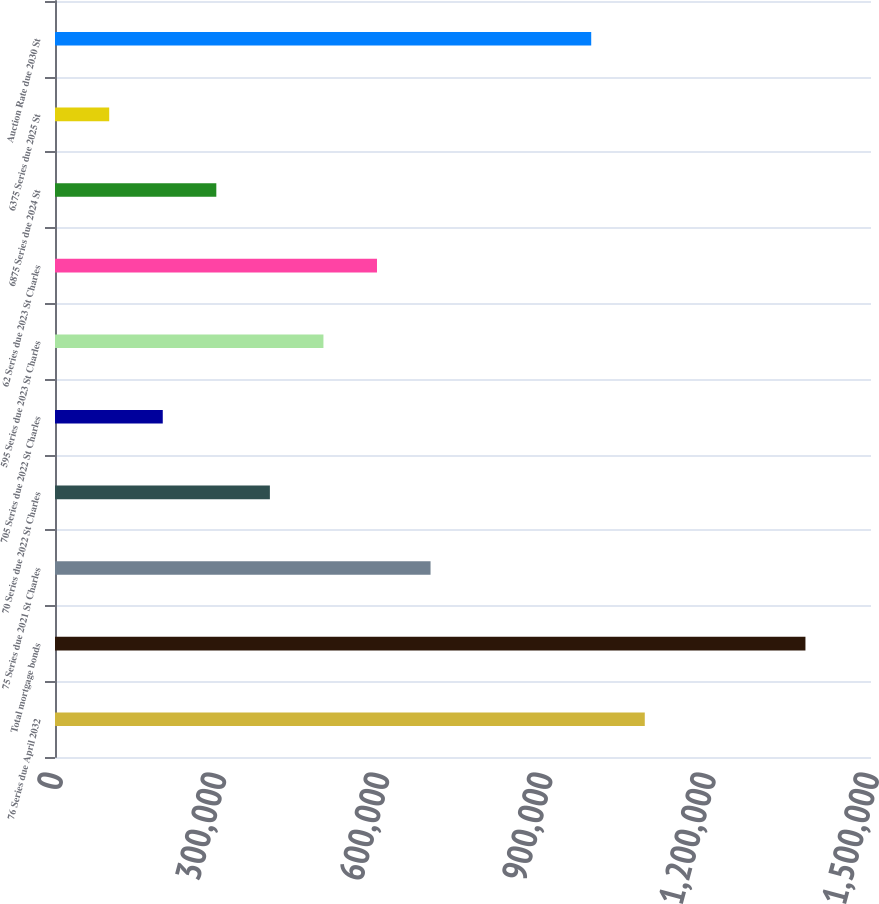<chart> <loc_0><loc_0><loc_500><loc_500><bar_chart><fcel>76 Series due April 2032<fcel>Total mortgage bonds<fcel>75 Series due 2021 St Charles<fcel>70 Series due 2022 St Charles<fcel>705 Series due 2022 St Charles<fcel>595 Series due 2023 St Charles<fcel>62 Series due 2023 St Charles<fcel>6875 Series due 2024 St<fcel>6375 Series due 2025 St<fcel>Auction Rate due 2030 St<nl><fcel>1.08414e+06<fcel>1.37949e+06<fcel>690346<fcel>394998<fcel>198099<fcel>493448<fcel>591897<fcel>296548<fcel>99649.5<fcel>985695<nl></chart> 